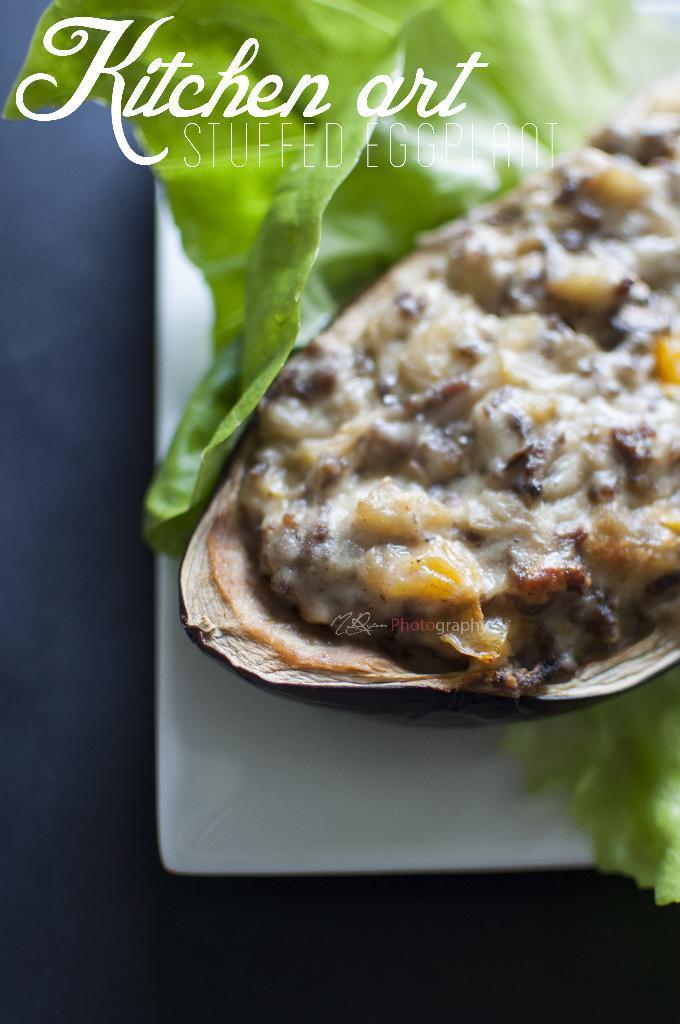Please provide a concise description of this image. In this picture we can see some food on a plate. A watermark is visible on top. 